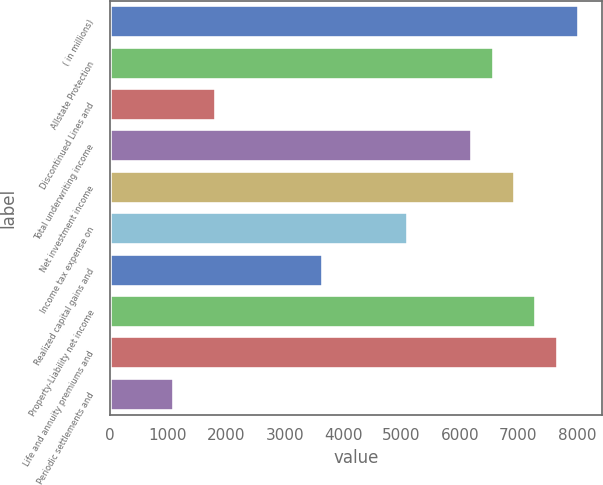Convert chart to OTSL. <chart><loc_0><loc_0><loc_500><loc_500><bar_chart><fcel>( in millions)<fcel>Allstate Protection<fcel>Discontinued Lines and<fcel>Total underwriting income<fcel>Net investment income<fcel>Income tax expense on<fcel>Realized capital gains and<fcel>Property-Liability net income<fcel>Life and annuity premiums and<fcel>Periodic settlements and<nl><fcel>8036.2<fcel>6575.8<fcel>1829.5<fcel>6210.7<fcel>6940.9<fcel>5115.4<fcel>3655<fcel>7306<fcel>7671.1<fcel>1099.3<nl></chart> 